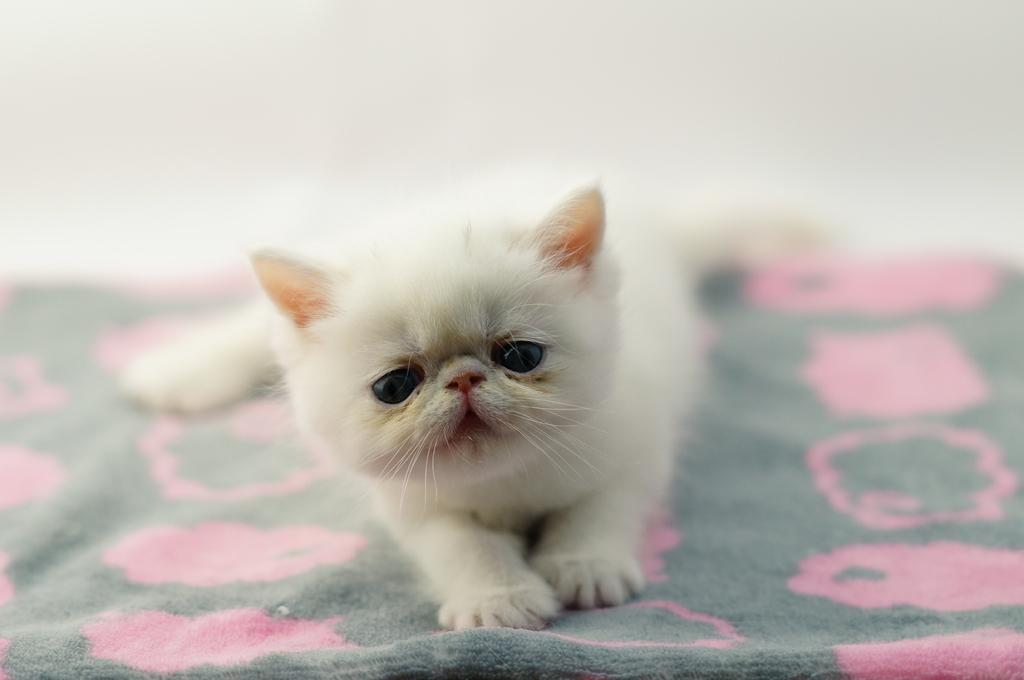What type of animal is in the image? There is a white kitten in the image. Where is the kitten located? The kitten is on a bed sheet. Can you describe the background of the image? The background of the image is blurred. How many wool balls are present in the image? There is no mention of wool balls in the image, so it is not possible to determine their number. 